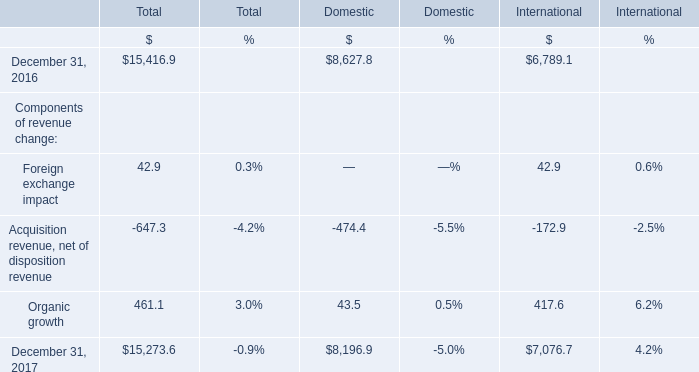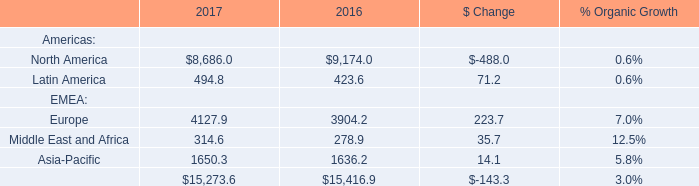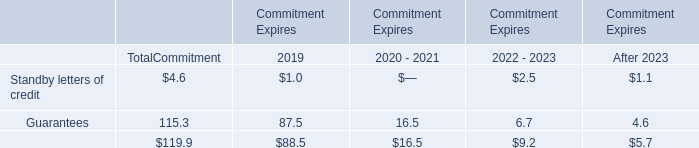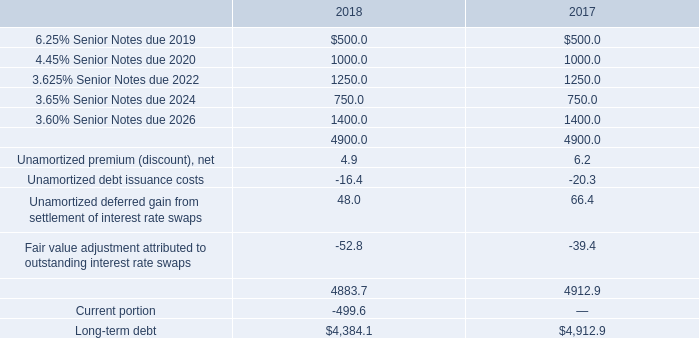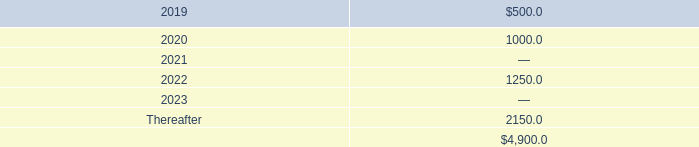What's the current growth rate of Components of revenue in total? (in %) 
Computations: ((15273.6 - 15416.9) / 15416.9)
Answer: -0.00929. 